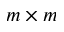Convert formula to latex. <formula><loc_0><loc_0><loc_500><loc_500>m \times m</formula> 